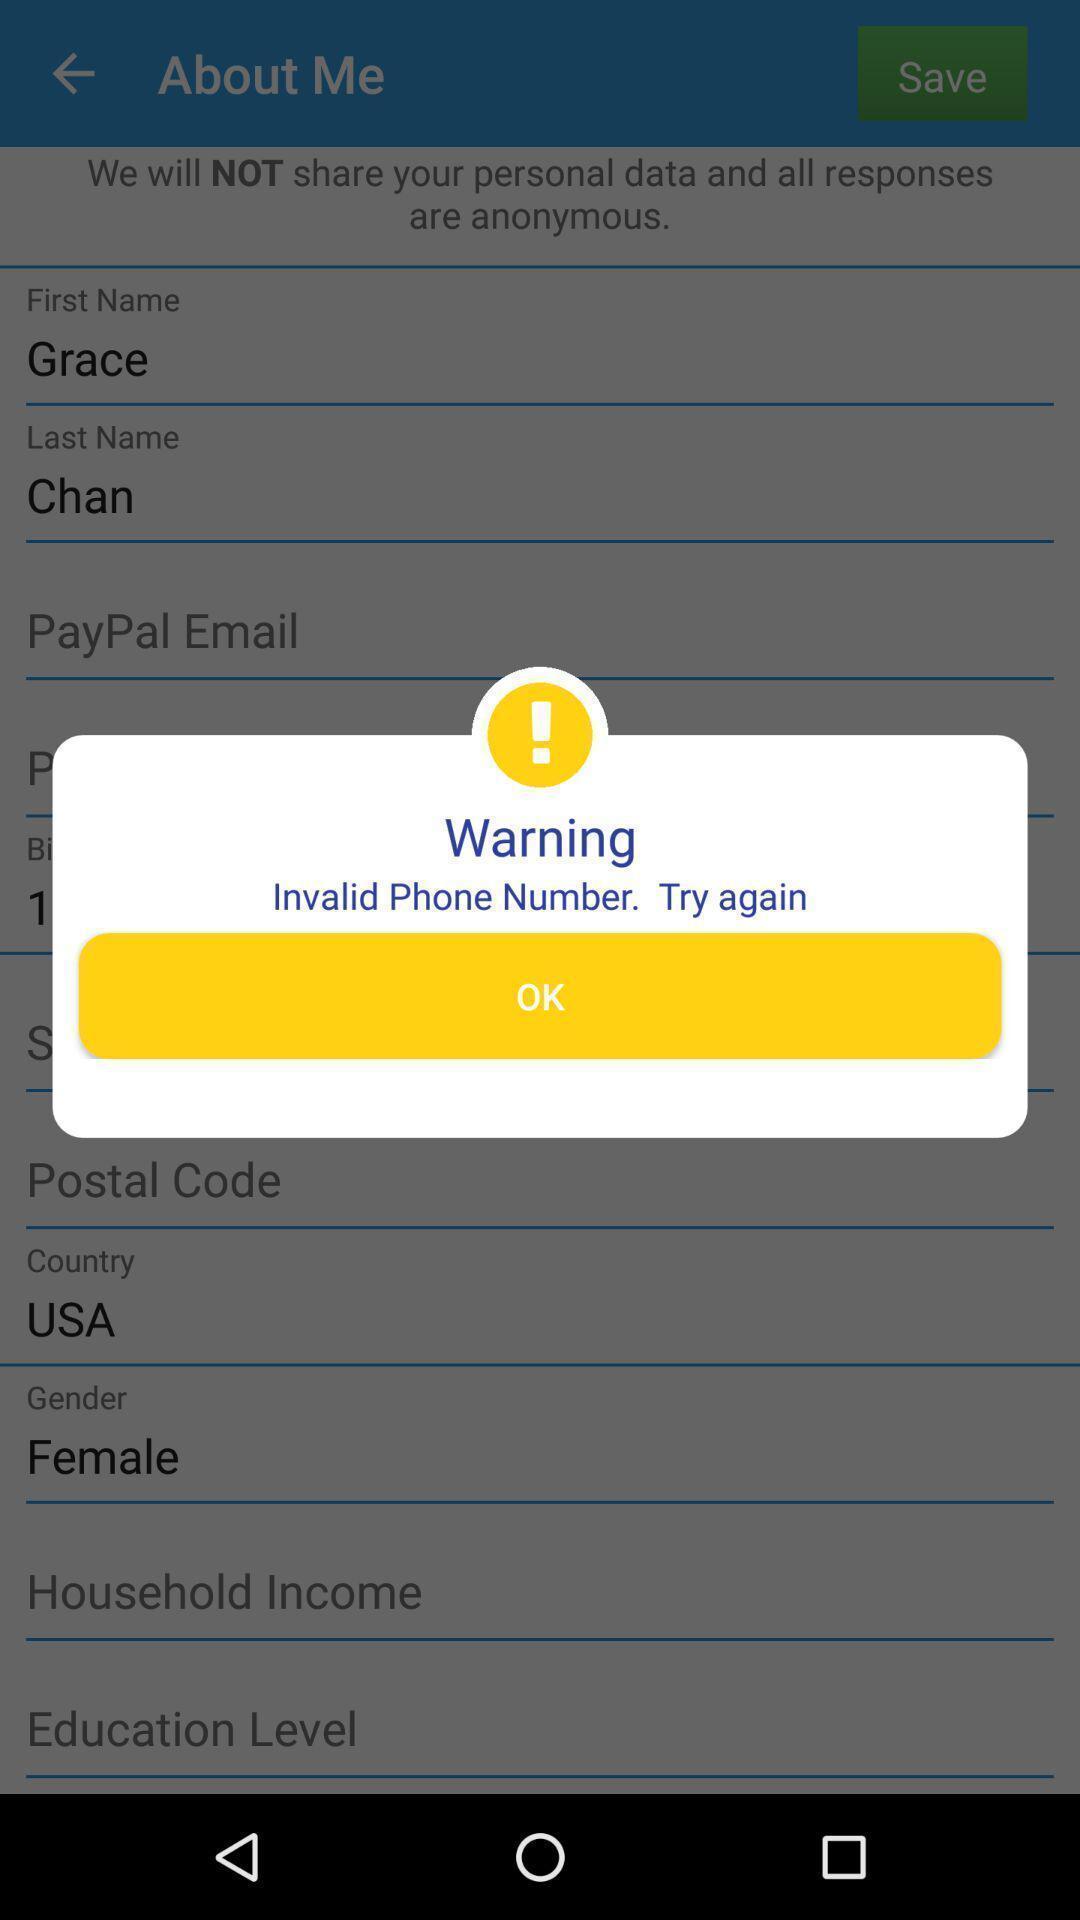Tell me about the visual elements in this screen capture. Pop-up showing a warning message. 